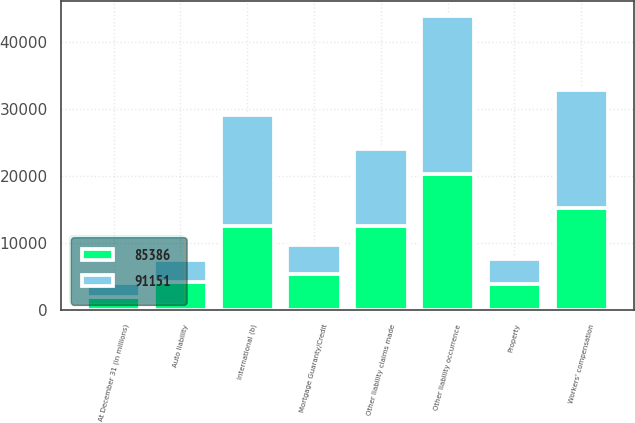Convert chart to OTSL. <chart><loc_0><loc_0><loc_500><loc_500><stacked_bar_chart><ecel><fcel>At December 31 (in millions)<fcel>Other liability occurrence<fcel>Workers' compensation<fcel>International (b)<fcel>Other liability claims made<fcel>Mortgage Guaranty/Credit<fcel>Property<fcel>Auto liability<nl><fcel>91151<fcel>2010<fcel>23583<fcel>17683<fcel>16583<fcel>11446<fcel>4220<fcel>3846<fcel>3337<nl><fcel>85386<fcel>2009<fcel>20344<fcel>15200<fcel>12582<fcel>12619<fcel>5477<fcel>3872<fcel>4164<nl></chart> 